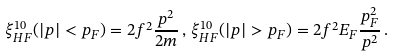Convert formula to latex. <formula><loc_0><loc_0><loc_500><loc_500>\xi _ { H F } ^ { 1 0 } ( | { p } | < p _ { F } ) = 2 f ^ { 2 } \frac { { p } ^ { 2 } } { 2 m } \, , \, \xi _ { H F } ^ { 1 0 } ( | { p } | > p _ { F } ) = 2 f ^ { 2 } E _ { F } \frac { p _ { F } ^ { 2 } } { { p } ^ { 2 } } \, .</formula> 